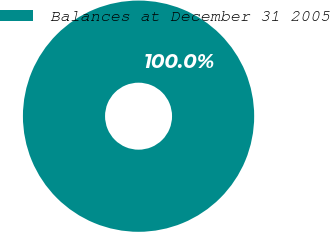<chart> <loc_0><loc_0><loc_500><loc_500><pie_chart><fcel>Balances at December 31 2005<nl><fcel>100.0%<nl></chart> 